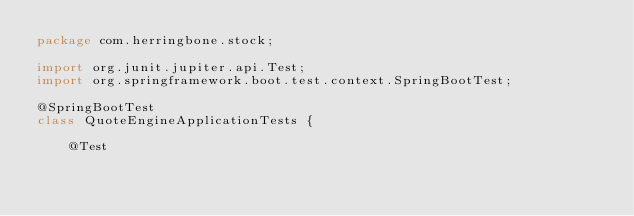Convert code to text. <code><loc_0><loc_0><loc_500><loc_500><_Java_>package com.herringbone.stock;

import org.junit.jupiter.api.Test;
import org.springframework.boot.test.context.SpringBootTest;

@SpringBootTest
class QuoteEngineApplicationTests {

    @Test</code> 